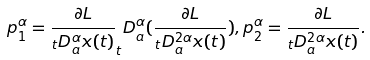Convert formula to latex. <formula><loc_0><loc_0><loc_500><loc_500>p _ { 1 } ^ { \alpha } = \frac { \partial L } { _ { t } D _ { a } ^ { \alpha } x ( t ) } _ { t } D _ { a } ^ { \alpha } ( \frac { \partial L } { _ { t } D _ { a } ^ { 2 \alpha } x ( t ) } ) , p _ { 2 } ^ { \alpha } = \frac { \partial L } { _ { t } D _ { a } ^ { 2 \alpha } x ( t ) } .</formula> 